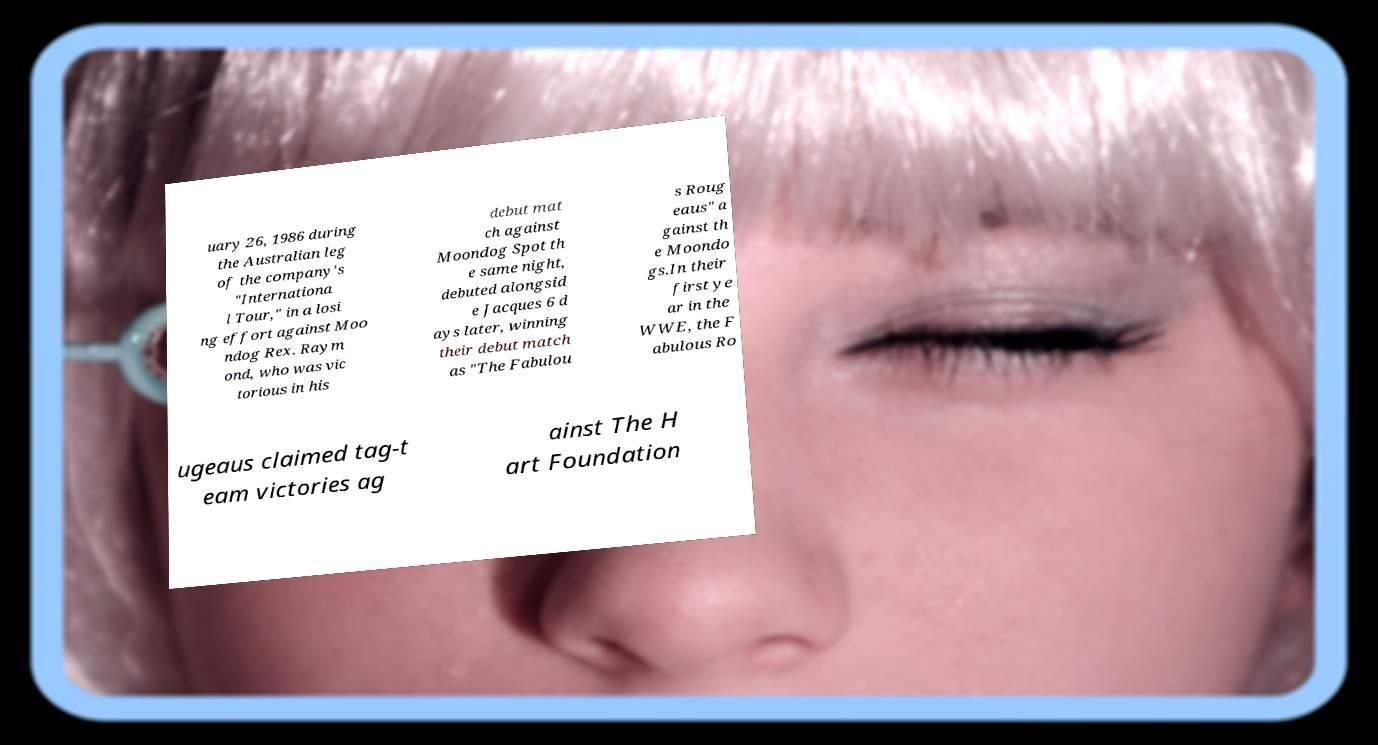I need the written content from this picture converted into text. Can you do that? uary 26, 1986 during the Australian leg of the company's "Internationa l Tour," in a losi ng effort against Moo ndog Rex. Raym ond, who was vic torious in his debut mat ch against Moondog Spot th e same night, debuted alongsid e Jacques 6 d ays later, winning their debut match as "The Fabulou s Roug eaus" a gainst th e Moondo gs.In their first ye ar in the WWE, the F abulous Ro ugeaus claimed tag-t eam victories ag ainst The H art Foundation 